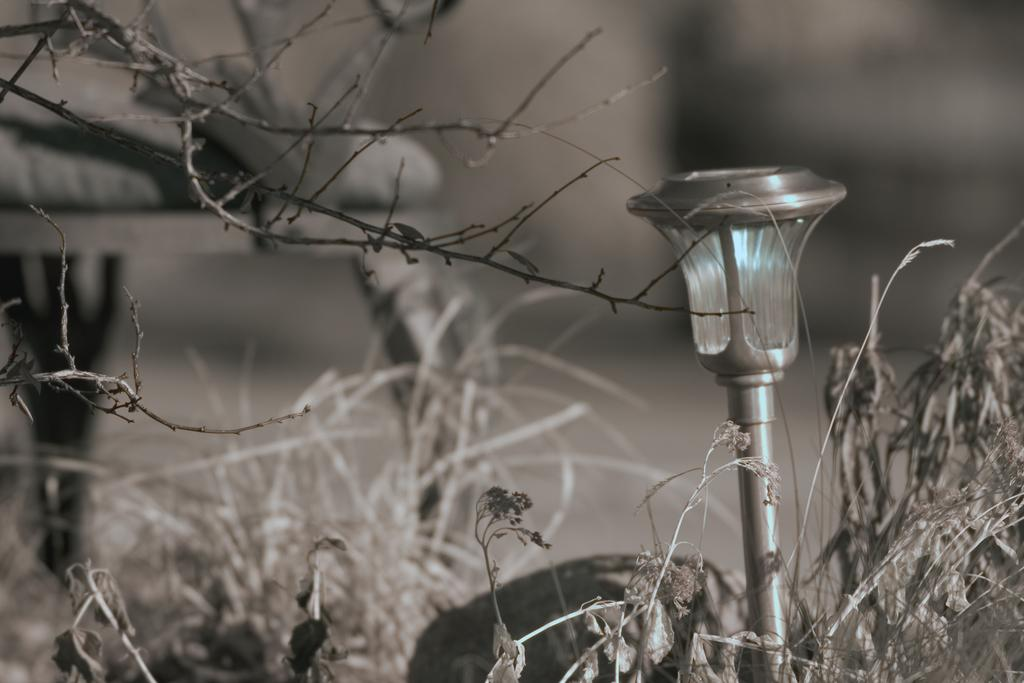What is the color scheme of the image? The image is black and white. What type of living organisms can be seen in the image? There are plants in the image. What metal object is present on the right side of the image? There is a metal object resembling a light on the right side of the image. How would you describe the background of the image? The background of the image is blurred. How many ears of corn are visible in the image? There are no ears of corn present in the image. What type of visitor can be seen interacting with the plants in the image? There are no visitors present in the image; it only features plants and a metal object resembling a light. 